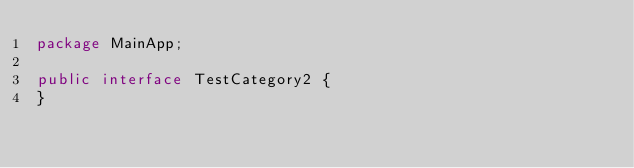<code> <loc_0><loc_0><loc_500><loc_500><_Java_>package MainApp;

public interface TestCategory2 {
}
</code> 